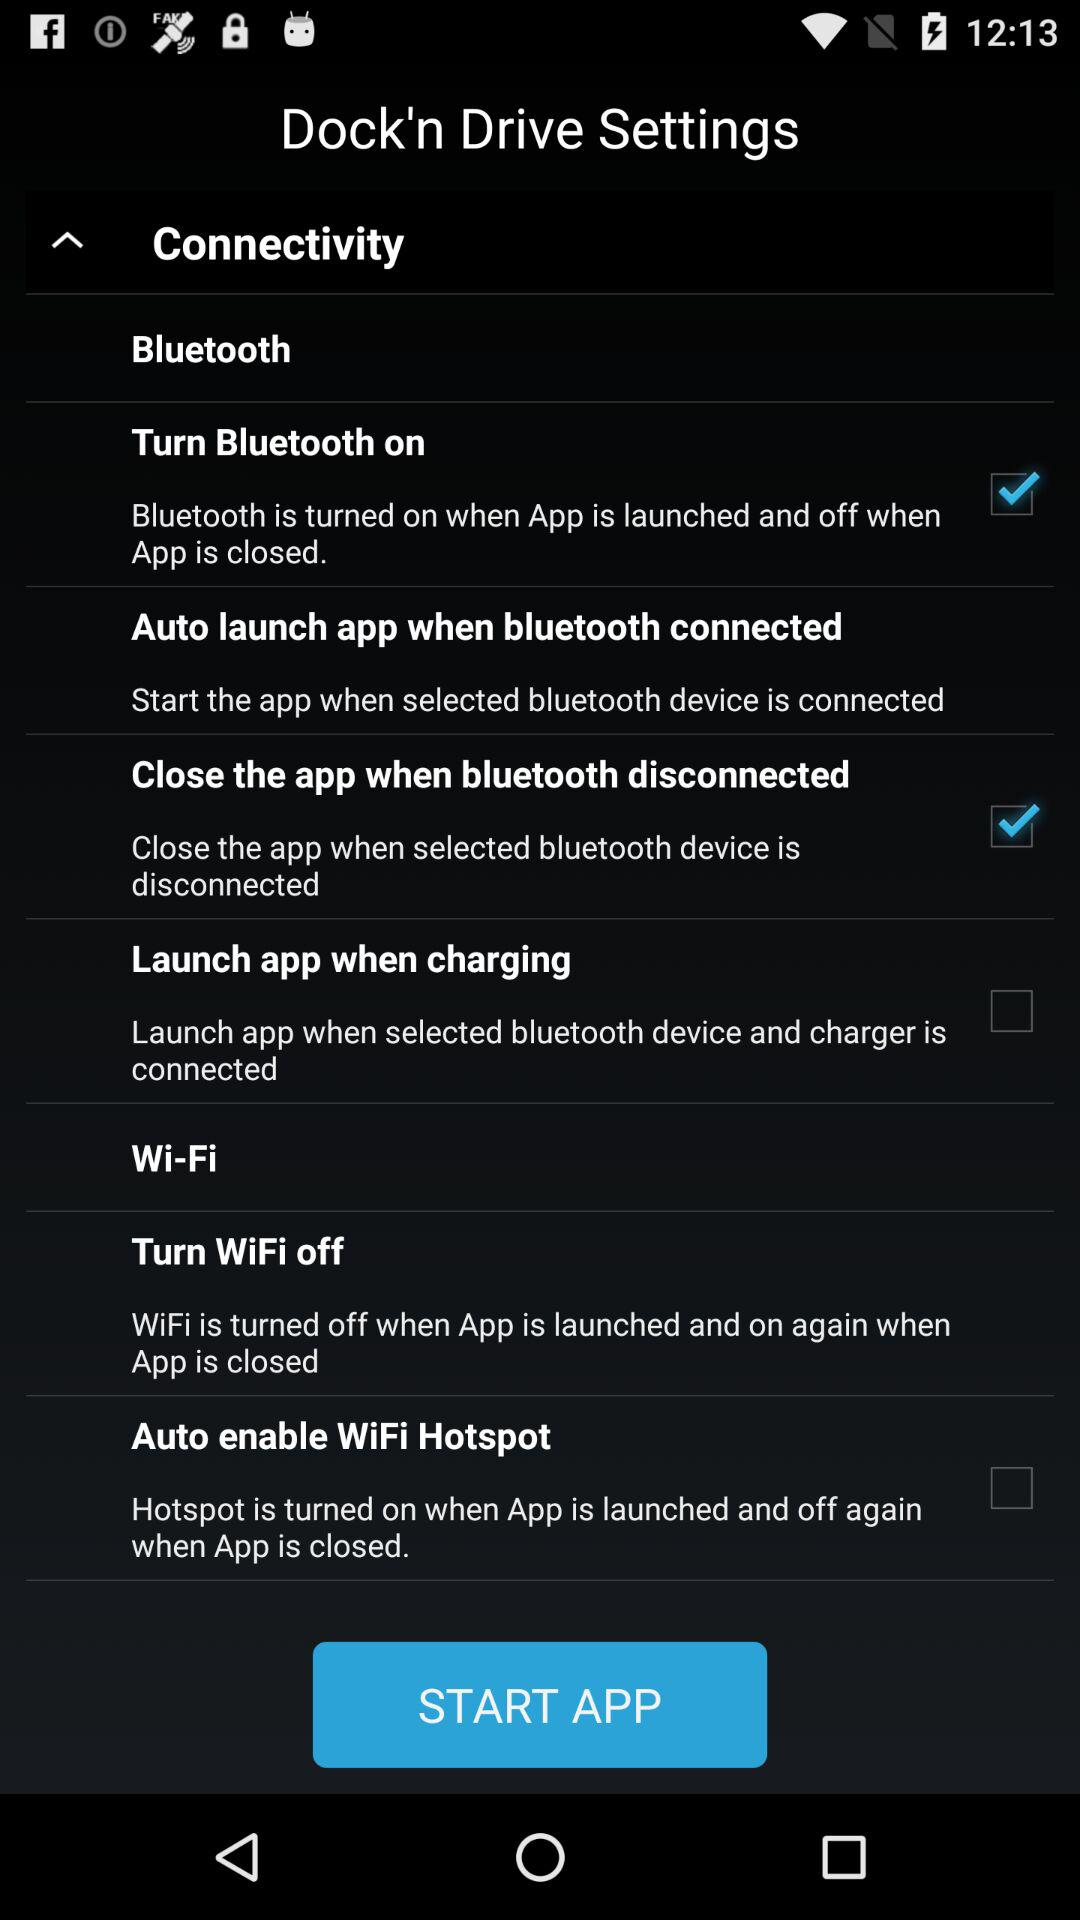Which Bluetooth device is connnected?
When the provided information is insufficient, respond with <no answer>. <no answer> 